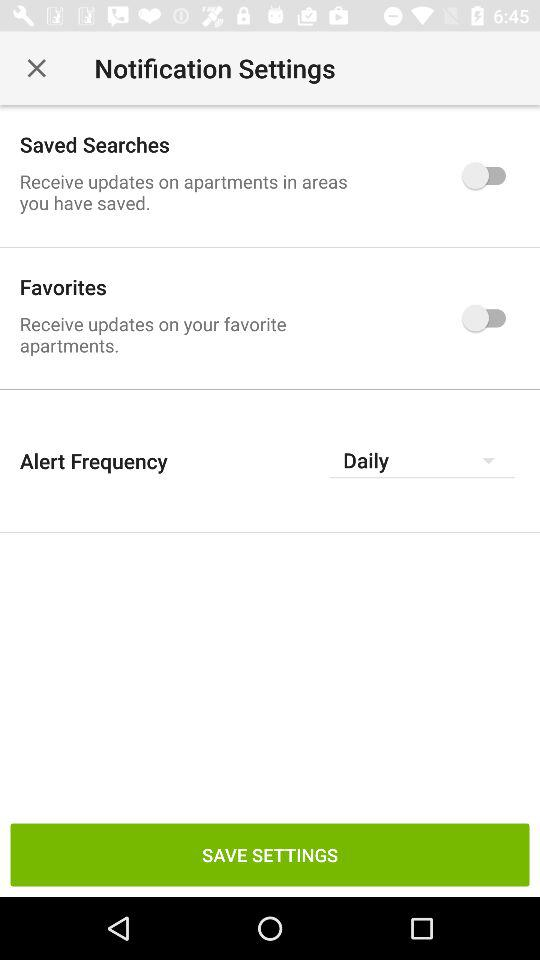What is the status of "Saved Searches"? The status of "Saved Searches" is "off". 